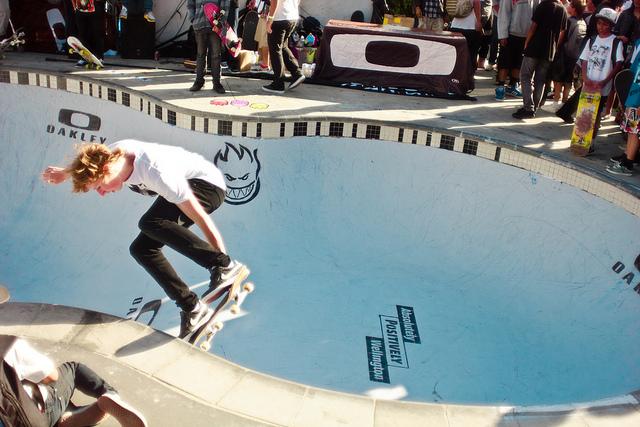Is this deep space a giant's footprint?
Answer briefly. No. What is the term for the place where the boy is skateboarding?
Write a very short answer. Skate park. What is the boy doing?
Give a very brief answer. Skateboarding. 